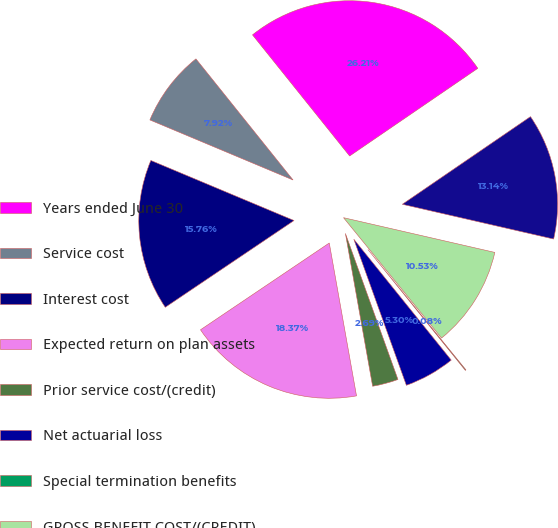Convert chart to OTSL. <chart><loc_0><loc_0><loc_500><loc_500><pie_chart><fcel>Years ended June 30<fcel>Service cost<fcel>Interest cost<fcel>Expected return on plan assets<fcel>Prior service cost/(credit)<fcel>Net actuarial loss<fcel>Special termination benefits<fcel>GROSS BENEFIT COST/(CREDIT)<fcel>NET PERIODIC BENEFIT<nl><fcel>26.21%<fcel>7.92%<fcel>15.76%<fcel>18.37%<fcel>2.69%<fcel>5.3%<fcel>0.08%<fcel>10.53%<fcel>13.14%<nl></chart> 